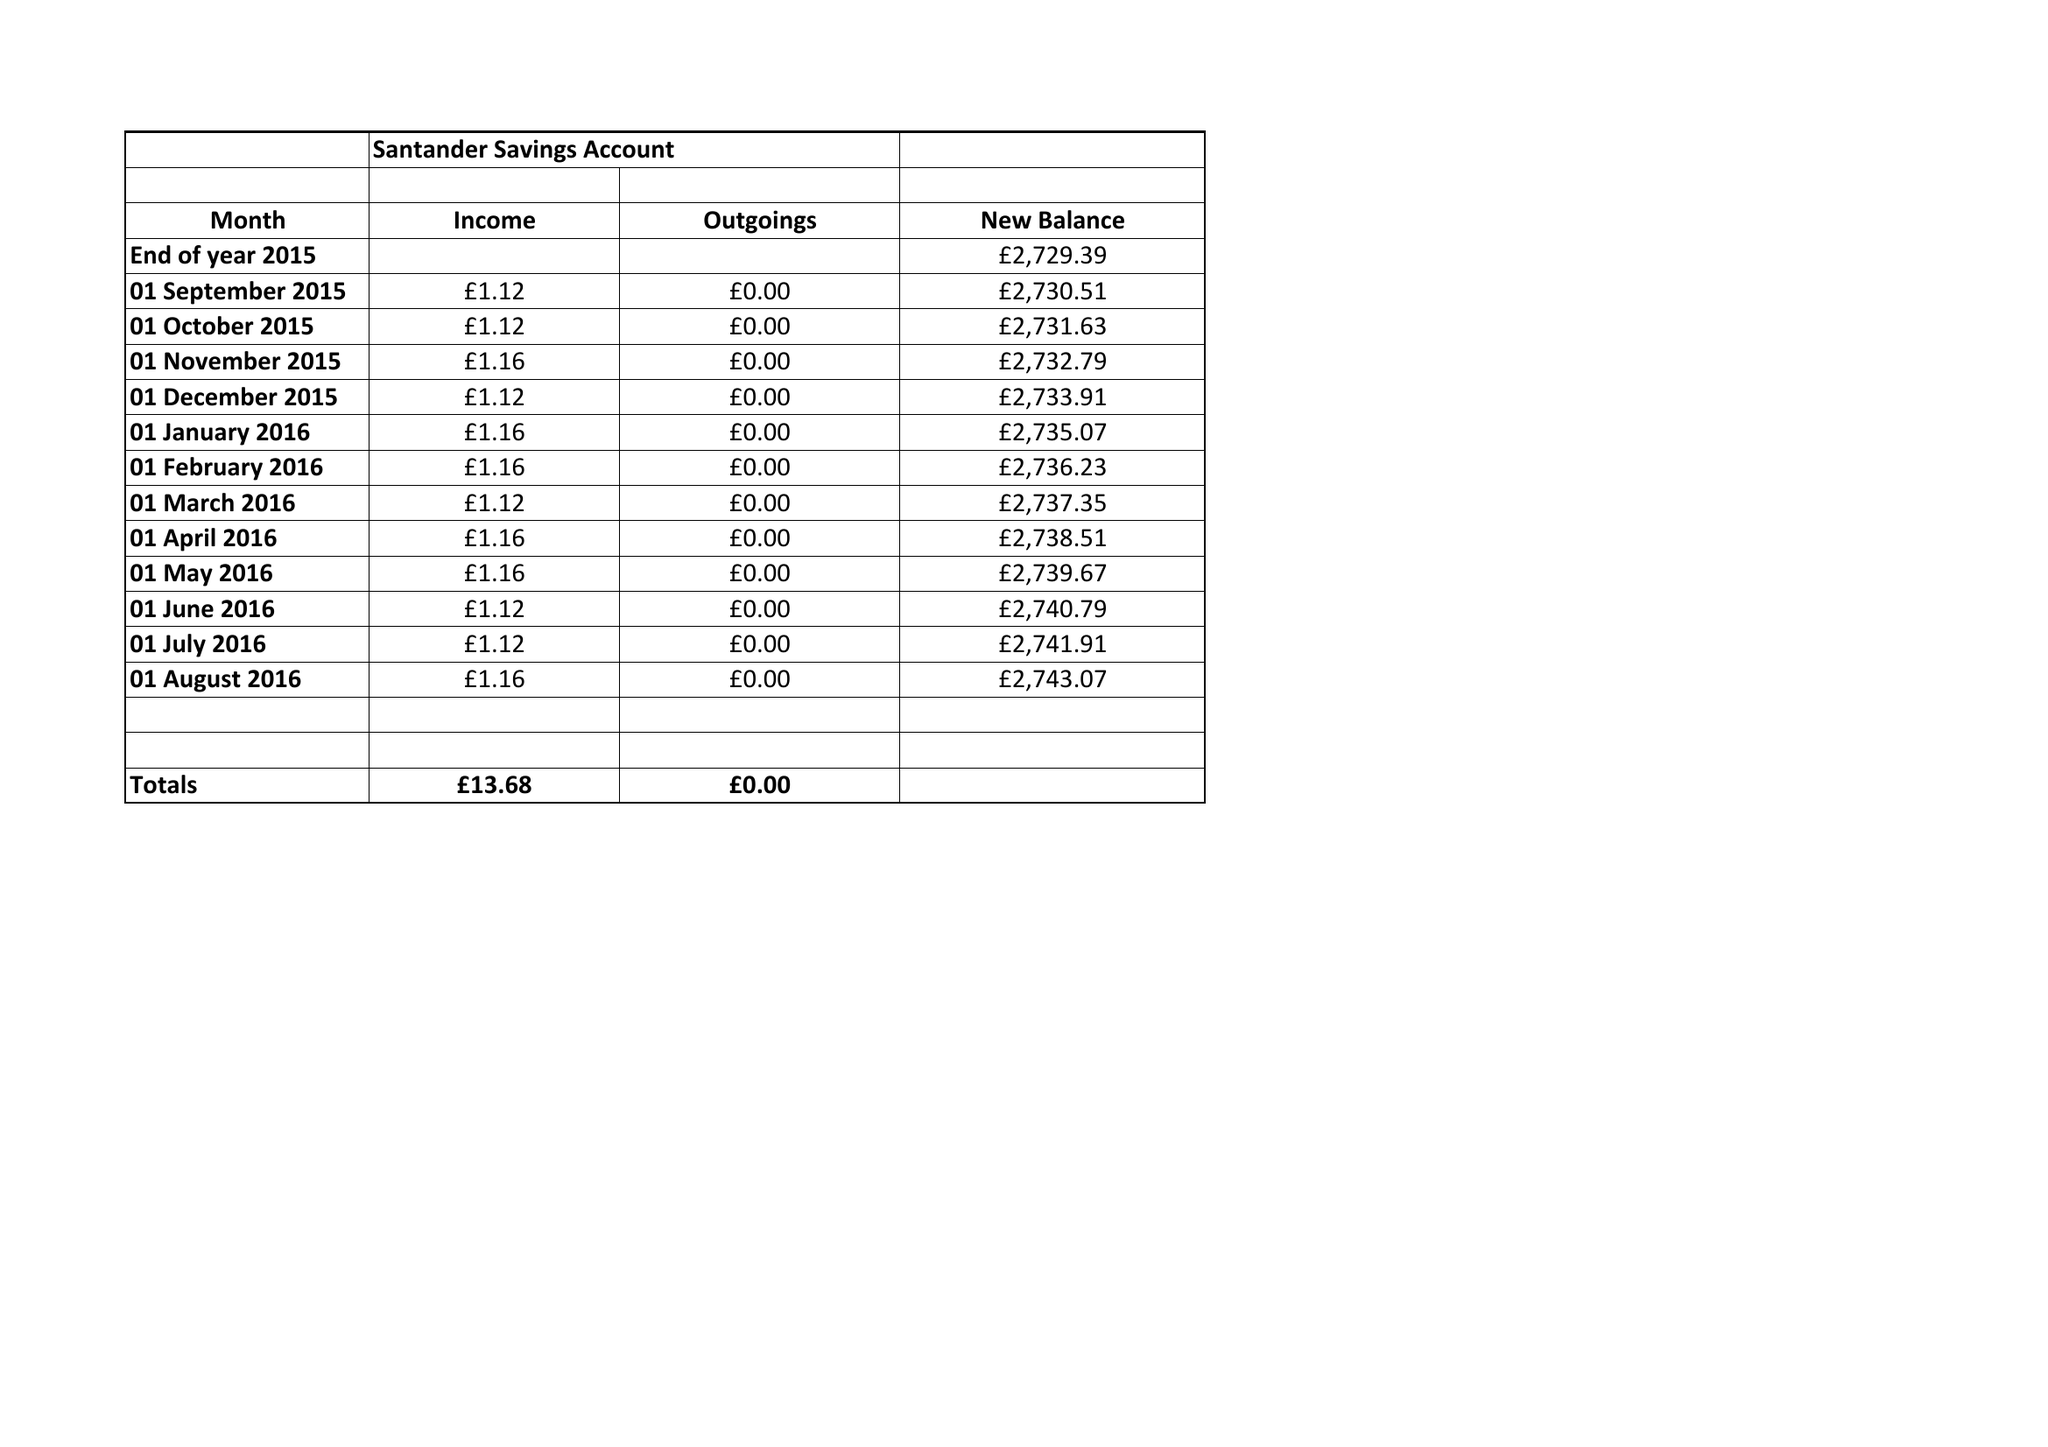What is the value for the spending_annually_in_british_pounds?
Answer the question using a single word or phrase. 59507.86 